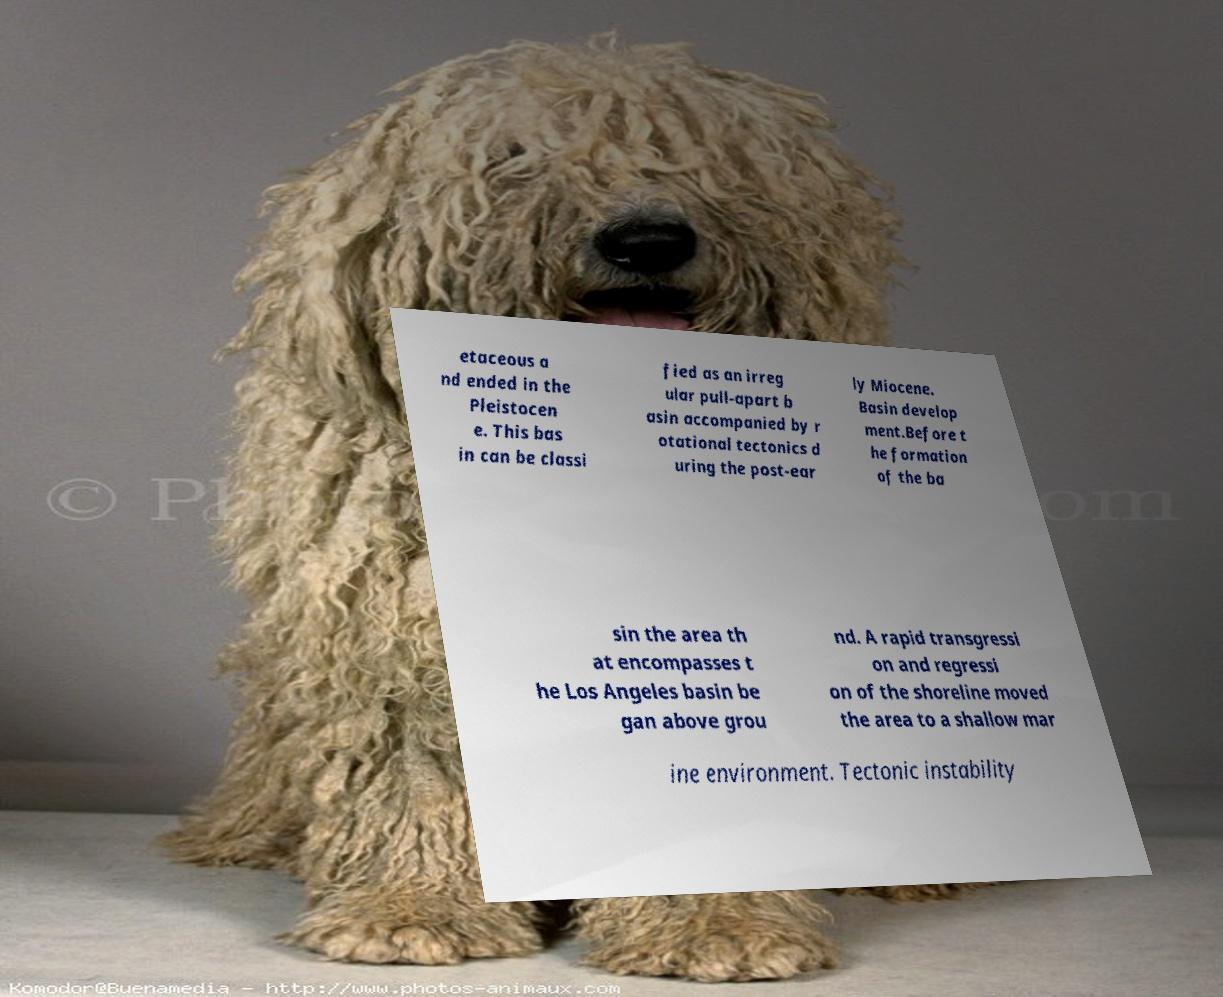Could you extract and type out the text from this image? etaceous a nd ended in the Pleistocen e. This bas in can be classi fied as an irreg ular pull-apart b asin accompanied by r otational tectonics d uring the post-ear ly Miocene. Basin develop ment.Before t he formation of the ba sin the area th at encompasses t he Los Angeles basin be gan above grou nd. A rapid transgressi on and regressi on of the shoreline moved the area to a shallow mar ine environment. Tectonic instability 